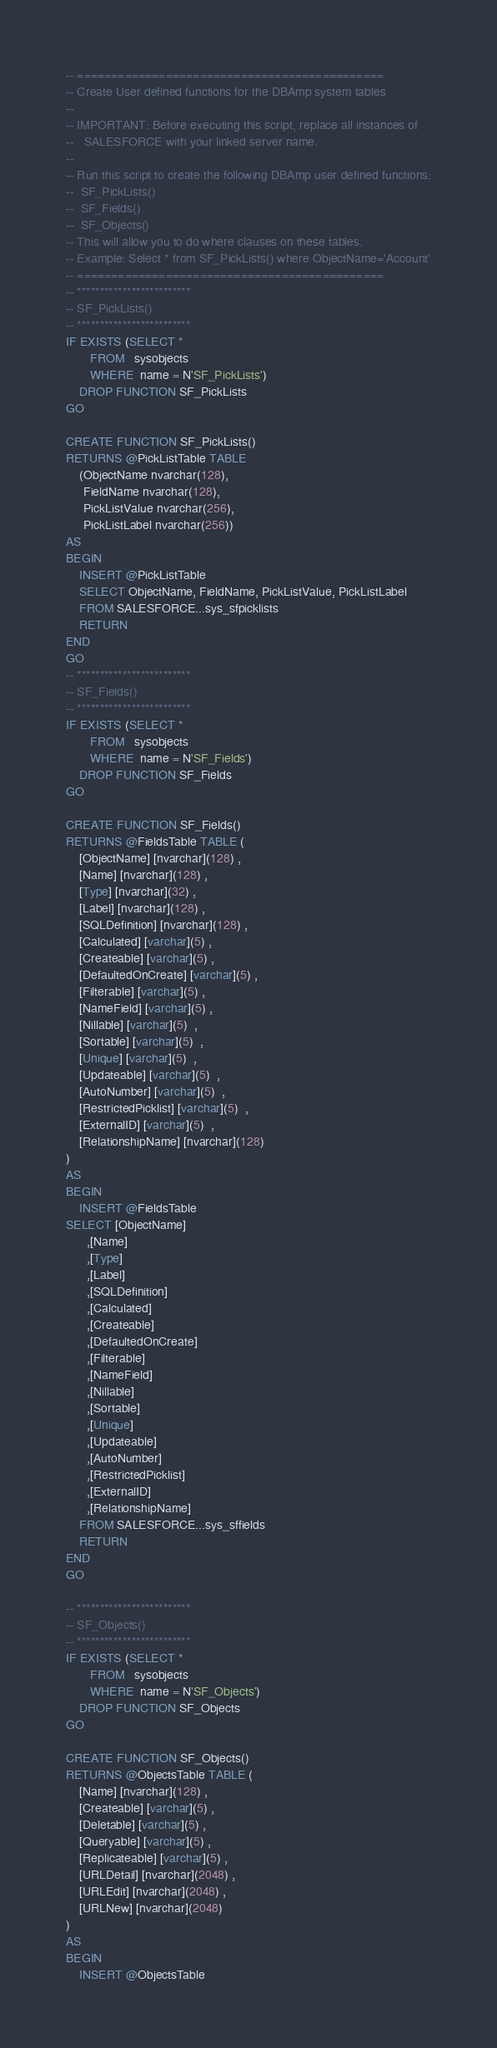<code> <loc_0><loc_0><loc_500><loc_500><_SQL_>-- =============================================
-- Create User defined functions for the DBAmp system tables
--
-- IMPORTANT: Before executing this script, replace all instances of
--   SALESFORCE with your linked server name.
--
-- Run this script to create the following DBAmp user defined functions:
--	SF_PickLists()
--  SF_Fields()
--  SF_Objects()
-- This will allow you to do where clauses on these tables.
-- Example: Select * from SF_PickLists() where ObjectName='Account'
-- =============================================
-- *************************
-- SF_PickLists()
-- *************************
IF EXISTS (SELECT * 
	   FROM   sysobjects 
	   WHERE  name = N'SF_PickLists')
	DROP FUNCTION SF_PickLists
GO

CREATE FUNCTION SF_PickLists()
RETURNS @PickListTable TABLE 
	(ObjectName nvarchar(128), 
	 FieldName nvarchar(128),
	 PickListValue nvarchar(256),
	 PickListLabel nvarchar(256))
AS
BEGIN
	INSERT @PickListTable
	SELECT ObjectName, FieldName, PickListValue, PickListLabel
	FROM SALESFORCE...sys_sfpicklists
	RETURN 
END
GO
-- *************************
-- SF_Fields()
-- *************************
IF EXISTS (SELECT * 
	   FROM   sysobjects 
	   WHERE  name = N'SF_Fields')
	DROP FUNCTION SF_Fields
GO

CREATE FUNCTION SF_Fields()
RETURNS @FieldsTable TABLE (
	[ObjectName] [nvarchar](128) ,
	[Name] [nvarchar](128) ,
	[Type] [nvarchar](32) ,
	[Label] [nvarchar](128) ,
	[SQLDefinition] [nvarchar](128) ,
	[Calculated] [varchar](5) ,
	[Createable] [varchar](5) ,
	[DefaultedOnCreate] [varchar](5) ,
	[Filterable] [varchar](5) ,
	[NameField] [varchar](5) ,
	[Nillable] [varchar](5)  ,
	[Sortable] [varchar](5)  ,
	[Unique] [varchar](5)  ,
	[Updateable] [varchar](5)  ,
	[AutoNumber] [varchar](5)  ,
	[RestrictedPicklist] [varchar](5)  ,
	[ExternalID] [varchar](5)  ,
	[RelationshipName] [nvarchar](128)  
)
AS
BEGIN
	INSERT @FieldsTable
SELECT [ObjectName]
      ,[Name]
      ,[Type]
      ,[Label]
      ,[SQLDefinition]
      ,[Calculated]
      ,[Createable]
      ,[DefaultedOnCreate]
      ,[Filterable]
      ,[NameField]
      ,[Nillable]
      ,[Sortable]
      ,[Unique]
      ,[Updateable]
      ,[AutoNumber]
      ,[RestrictedPicklist]
      ,[ExternalID]
      ,[RelationshipName]
	FROM SALESFORCE...sys_sffields
	RETURN 
END
GO

-- *************************
-- SF_Objects()
-- *************************
IF EXISTS (SELECT * 
	   FROM   sysobjects 
	   WHERE  name = N'SF_Objects')
	DROP FUNCTION SF_Objects
GO

CREATE FUNCTION SF_Objects()
RETURNS @ObjectsTable TABLE (
	[Name] [nvarchar](128) ,
	[Createable] [varchar](5) ,
	[Deletable] [varchar](5) ,
	[Queryable] [varchar](5) ,
	[Replicateable] [varchar](5) ,
	[URLDetail] [nvarchar](2048) ,
	[URLEdit] [nvarchar](2048) ,
	[URLNew] [nvarchar](2048) 
)
AS
BEGIN
	INSERT @ObjectsTable</code> 